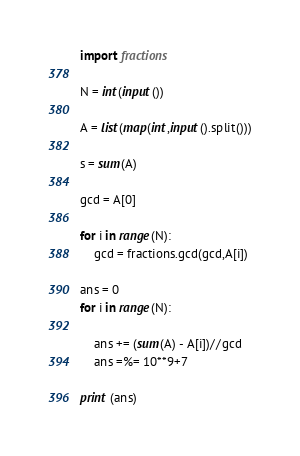Convert code to text. <code><loc_0><loc_0><loc_500><loc_500><_Python_>
import fractions

N = int(input())

A = list(map(int,input().split()))

s = sum(A)

gcd = A[0]

for i in range(N):
    gcd = fractions.gcd(gcd,A[i])

ans = 0
for i in range(N):

    ans += (sum(A) - A[i])//gcd
    ans =%= 10**9+7

print (ans)</code> 